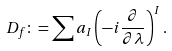<formula> <loc_0><loc_0><loc_500><loc_500>D _ { f } \colon = \sum a _ { I } \left ( - i \frac { \partial } { \partial \lambda } \right ) ^ { I } .</formula> 